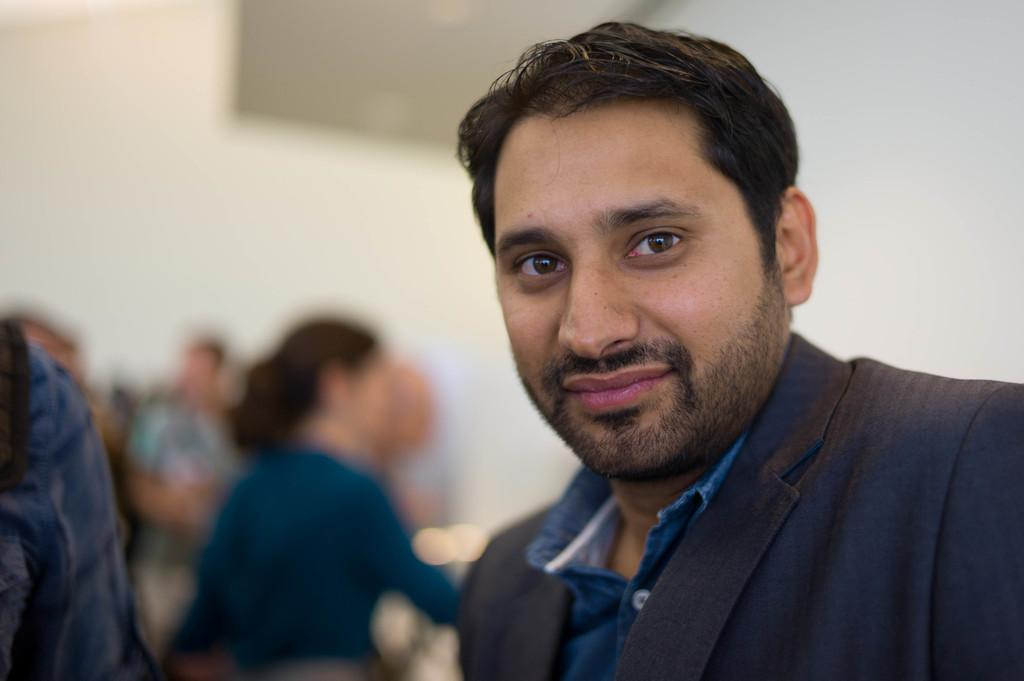Who is the main subject in the image? There is a man in the image. What is the man wearing? The man is wearing a blue suit. Can you describe the background of the image? The background of the image is blurred, and there are many people visible. What type of belief can be seen in the man's vein in the image? There is no indication of a belief or vein in the image; it features a man wearing a blue suit with a blurred background. 